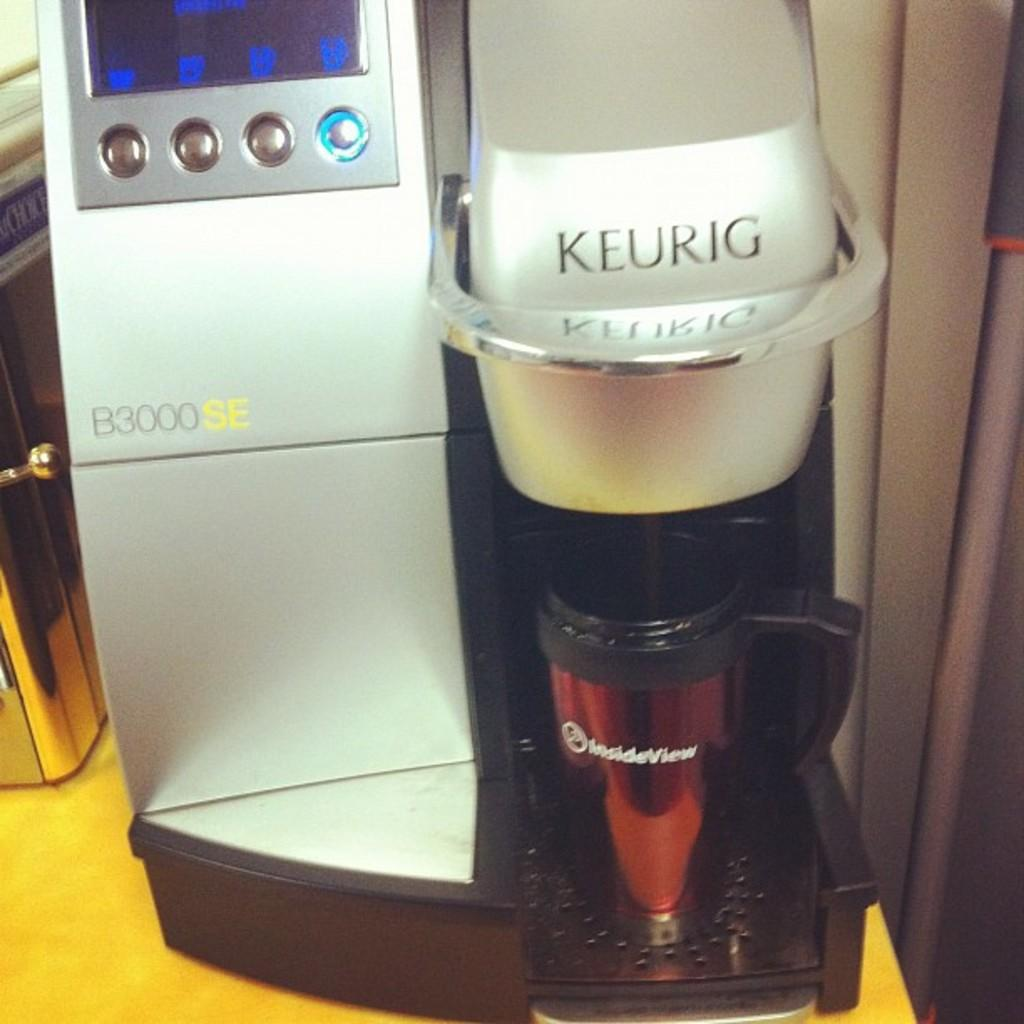<image>
Render a clear and concise summary of the photo. A Keurig B3000SE machine is dispensing something into an InsideView coffee mug. 